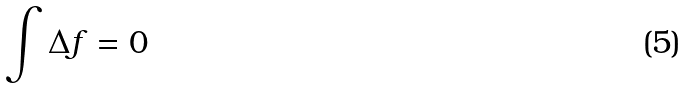Convert formula to latex. <formula><loc_0><loc_0><loc_500><loc_500>\int \Delta f = 0</formula> 